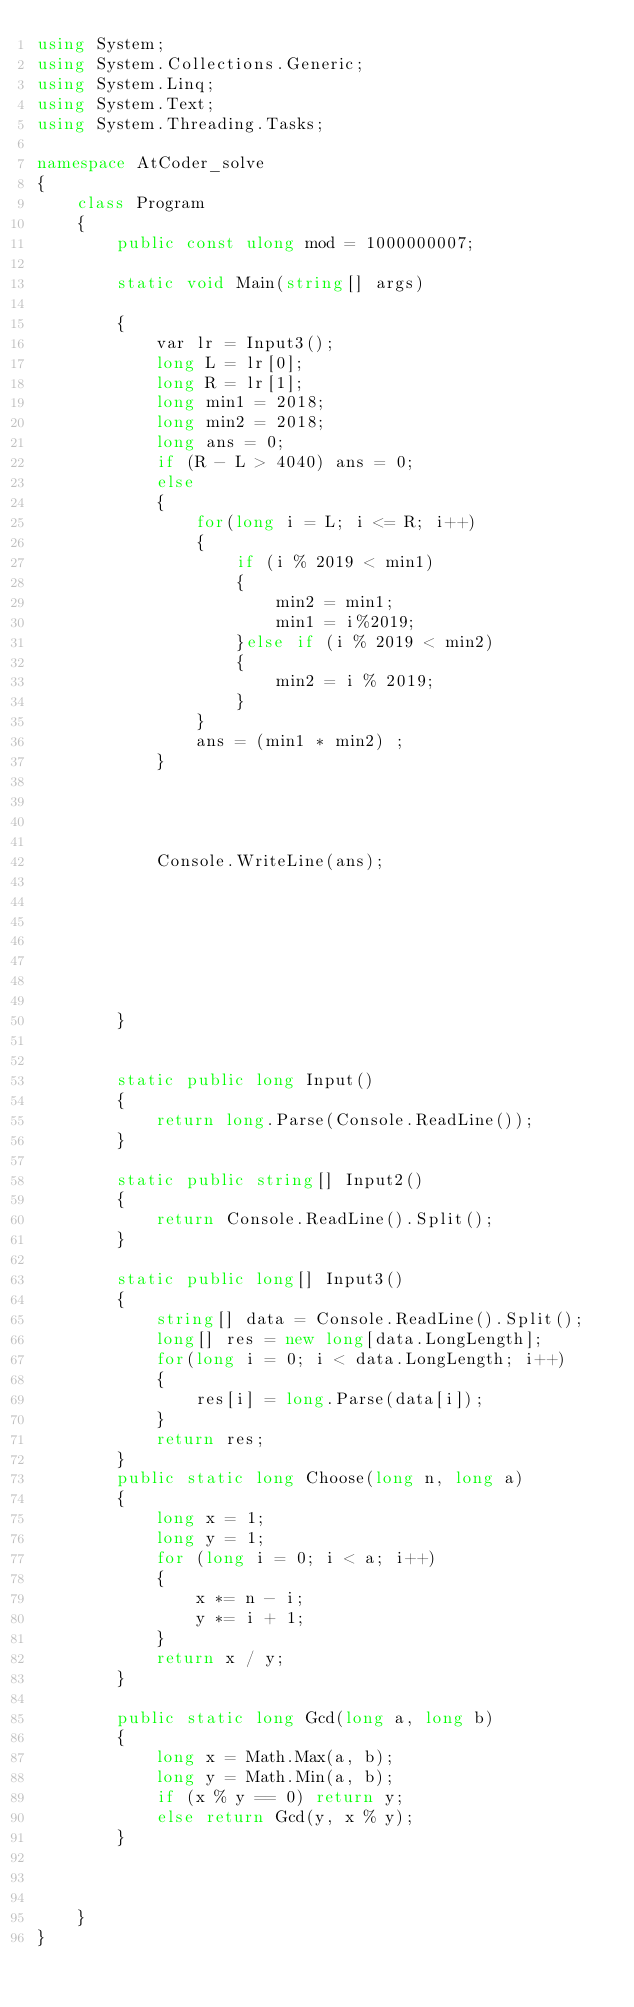<code> <loc_0><loc_0><loc_500><loc_500><_C#_>using System;
using System.Collections.Generic;
using System.Linq;
using System.Text;
using System.Threading.Tasks;

namespace AtCoder_solve
{
    class Program
    {
        public const ulong mod = 1000000007;

        static void Main(string[] args)

        {
            var lr = Input3();
            long L = lr[0];
            long R = lr[1];
            long min1 = 2018;
            long min2 = 2018;
            long ans = 0;
            if (R - L > 4040) ans = 0;
            else
            {
                for(long i = L; i <= R; i++)
                {
                    if (i % 2019 < min1)
                    {
                        min2 = min1;
                        min1 = i%2019;
                    }else if (i % 2019 < min2)
                    {
                        min2 = i % 2019;
                    }
                }
                ans = (min1 * min2) ;
            }
            

           
            
            Console.WriteLine(ans);
                
                





        }

       
        static public long Input()
        {
            return long.Parse(Console.ReadLine());
        }

        static public string[] Input2()
        {
            return Console.ReadLine().Split();
        }

        static public long[] Input3()
        {
            string[] data = Console.ReadLine().Split();
            long[] res = new long[data.LongLength];
            for(long i = 0; i < data.LongLength; i++)
            {
                res[i] = long.Parse(data[i]);
            }
            return res;
        }
        public static long Choose(long n, long a)
        {
            long x = 1;
            long y = 1;
            for (long i = 0; i < a; i++)
            {
                x *= n - i;
                y *= i + 1;
            }
            return x / y;
        }

        public static long Gcd(long a, long b)
        {
            long x = Math.Max(a, b);
            long y = Math.Min(a, b);
            if (x % y == 0) return y;
            else return Gcd(y, x % y);
        }

        
       
    }
}
</code> 